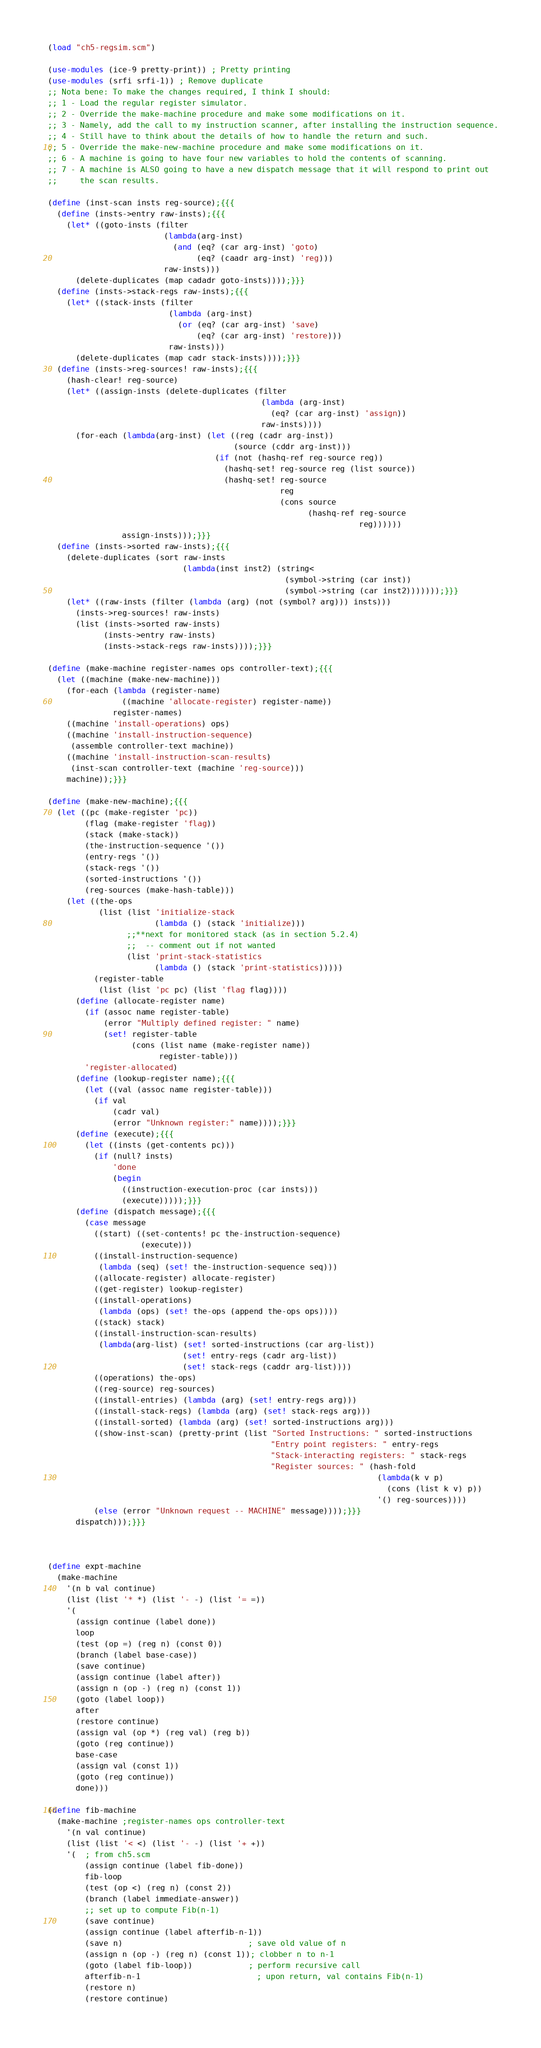<code> <loc_0><loc_0><loc_500><loc_500><_Scheme_>(load "ch5-regsim.scm")

(use-modules (ice-9 pretty-print)) ; Pretty printing
(use-modules (srfi srfi-1)) ; Remove duplicate
;; Nota bene: To make the changes required, I think I should:
;; 1 - Load the regular register simulator.
;; 2 - Override the make-machine procedure and make some modifications on it.
;; 3 - Namely, add the call to my instruction scanner, after installing the instruction sequence.
;; 4 - Still have to think about the details of how to handle the return and such.
;; 5 - Override the make-new-machine procedure and make some modifications on it.
;; 6 - A machine is going to have four new variables to hold the contents of scanning.
;; 7 - A machine is ALSO going to have a new dispatch message that it will respond to print out
;;     the scan results.

(define (inst-scan insts reg-source);{{{
  (define (insts->entry raw-insts);{{{
    (let* ((goto-insts (filter
                         (lambda(arg-inst)
                           (and (eq? (car arg-inst) 'goto)
                                (eq? (caadr arg-inst) 'reg)))
                         raw-insts)))
      (delete-duplicates (map cadadr goto-insts))));}}}
  (define (insts->stack-regs raw-insts);{{{
    (let* ((stack-insts (filter
                          (lambda (arg-inst)
                            (or (eq? (car arg-inst) 'save)
                                (eq? (car arg-inst) 'restore)))
                          raw-insts)))
      (delete-duplicates (map cadr stack-insts))));}}}
  (define (insts->reg-sources! raw-insts);{{{
    (hash-clear! reg-source)
    (let* ((assign-insts (delete-duplicates (filter 
                                              (lambda (arg-inst)
                                                (eq? (car arg-inst) 'assign))
                                              raw-insts))))
      (for-each (lambda(arg-inst) (let ((reg (cadr arg-inst))
                                        (source (cddr arg-inst)))
                                    (if (not (hashq-ref reg-source reg))
                                      (hashq-set! reg-source reg (list source))
                                      (hashq-set! reg-source
                                                  reg
                                                  (cons source
                                                        (hashq-ref reg-source
                                                                   reg))))))
                assign-insts)));}}}
  (define (insts->sorted raw-insts);{{{
    (delete-duplicates (sort raw-insts 
                             (lambda(inst inst2) (string< 
                                                   (symbol->string (car inst))
                                                   (symbol->string (car inst2)))))));}}}
    (let* ((raw-insts (filter (lambda (arg) (not (symbol? arg))) insts)))
      (insts->reg-sources! raw-insts)
      (list (insts->sorted raw-insts)
            (insts->entry raw-insts)
            (insts->stack-regs raw-insts))));}}}

(define (make-machine register-names ops controller-text);{{{
  (let ((machine (make-new-machine)))
    (for-each (lambda (register-name)
                ((machine 'allocate-register) register-name))
              register-names)
    ((machine 'install-operations) ops)    
    ((machine 'install-instruction-sequence)
     (assemble controller-text machine))
    ((machine 'install-instruction-scan-results)
     (inst-scan controller-text (machine 'reg-source)))
    machine));}}}

(define (make-new-machine);{{{
  (let ((pc (make-register 'pc))
        (flag (make-register 'flag))
        (stack (make-stack))
        (the-instruction-sequence '())
        (entry-regs '())
        (stack-regs '())
        (sorted-instructions '())
        (reg-sources (make-hash-table)))
    (let ((the-ops
           (list (list 'initialize-stack
                       (lambda () (stack 'initialize)))
                 ;;**next for monitored stack (as in section 5.2.4)
                 ;;  -- comment out if not wanted
                 (list 'print-stack-statistics
                       (lambda () (stack 'print-statistics)))))
          (register-table
           (list (list 'pc pc) (list 'flag flag))))
      (define (allocate-register name)
        (if (assoc name register-table)
            (error "Multiply defined register: " name)
            (set! register-table
                  (cons (list name (make-register name))
                        register-table)))
        'register-allocated)
      (define (lookup-register name);{{{
        (let ((val (assoc name register-table)))
          (if val
              (cadr val)
              (error "Unknown register:" name))));}}}
      (define (execute);{{{
        (let ((insts (get-contents pc)))
          (if (null? insts)
              'done
              (begin
                ((instruction-execution-proc (car insts)))
                (execute)))));}}}
      (define (dispatch message);{{{
        (case message
          ((start) ((set-contents! pc the-instruction-sequence)
                    (execute)))
          ((install-instruction-sequence)
           (lambda (seq) (set! the-instruction-sequence seq)))
          ((allocate-register) allocate-register)
          ((get-register) lookup-register)
          ((install-operations) 
           (lambda (ops) (set! the-ops (append the-ops ops))))
          ((stack) stack)
          ((install-instruction-scan-results) 
           (lambda(arg-list) (set! sorted-instructions (car arg-list))
                             (set! entry-regs (cadr arg-list))
                             (set! stack-regs (caddr arg-list))))
          ((operations) the-ops)
          ((reg-source) reg-sources)
          ((install-entries) (lambda (arg) (set! entry-regs arg)))
          ((install-stack-regs) (lambda (arg) (set! stack-regs arg)))
          ((install-sorted) (lambda (arg) (set! sorted-instructions arg)))
          ((show-inst-scan) (pretty-print (list "Sorted Instructions: " sorted-instructions
                                                "Entry point registers: " entry-regs
                                                "Stack-interacting registers: " stack-regs
                                                "Register sources: " (hash-fold
                                                                       (lambda(k v p)
                                                                         (cons (list k v) p))
                                                                       '() reg-sources))))
          (else (error "Unknown request -- MACHINE" message))));}}}
      dispatch)));}}}



(define expt-machine
  (make-machine
    '(n b val continue)
    (list (list '* *) (list '- -) (list '= =))
    '(
      (assign continue (label done))
      loop
      (test (op =) (reg n) (const 0))
      (branch (label base-case))
      (save continue)
      (assign continue (label after))
      (assign n (op -) (reg n) (const 1))
      (goto (label loop))
      after
      (restore continue)
      (assign val (op *) (reg val) (reg b))
      (goto (reg continue))
      base-case
      (assign val (const 1))   
      (goto (reg continue))
      done)))

(define fib-machine 
  (make-machine ;register-names ops controller-text 
    '(n val continue) 
    (list (list '< <) (list '- -) (list '+ +)) 
    '(  ; from ch5.scm 
        (assign continue (label fib-done)) 
        fib-loop 
        (test (op <) (reg n) (const 2)) 
        (branch (label immediate-answer)) 
        ;; set up to compute Fib(n-1) 
        (save continue) 
        (assign continue (label afterfib-n-1)) 
        (save n)                           ; save old value of n 
        (assign n (op -) (reg n) (const 1)); clobber n to n-1 
        (goto (label fib-loop))            ; perform recursive call 
        afterfib-n-1                         ; upon return, val contains Fib(n-1) 
        (restore n) 
        (restore continue) </code> 